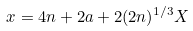Convert formula to latex. <formula><loc_0><loc_0><loc_500><loc_500>x = 4 n + 2 a + 2 ( 2 n ) ^ { 1 / 3 } X</formula> 